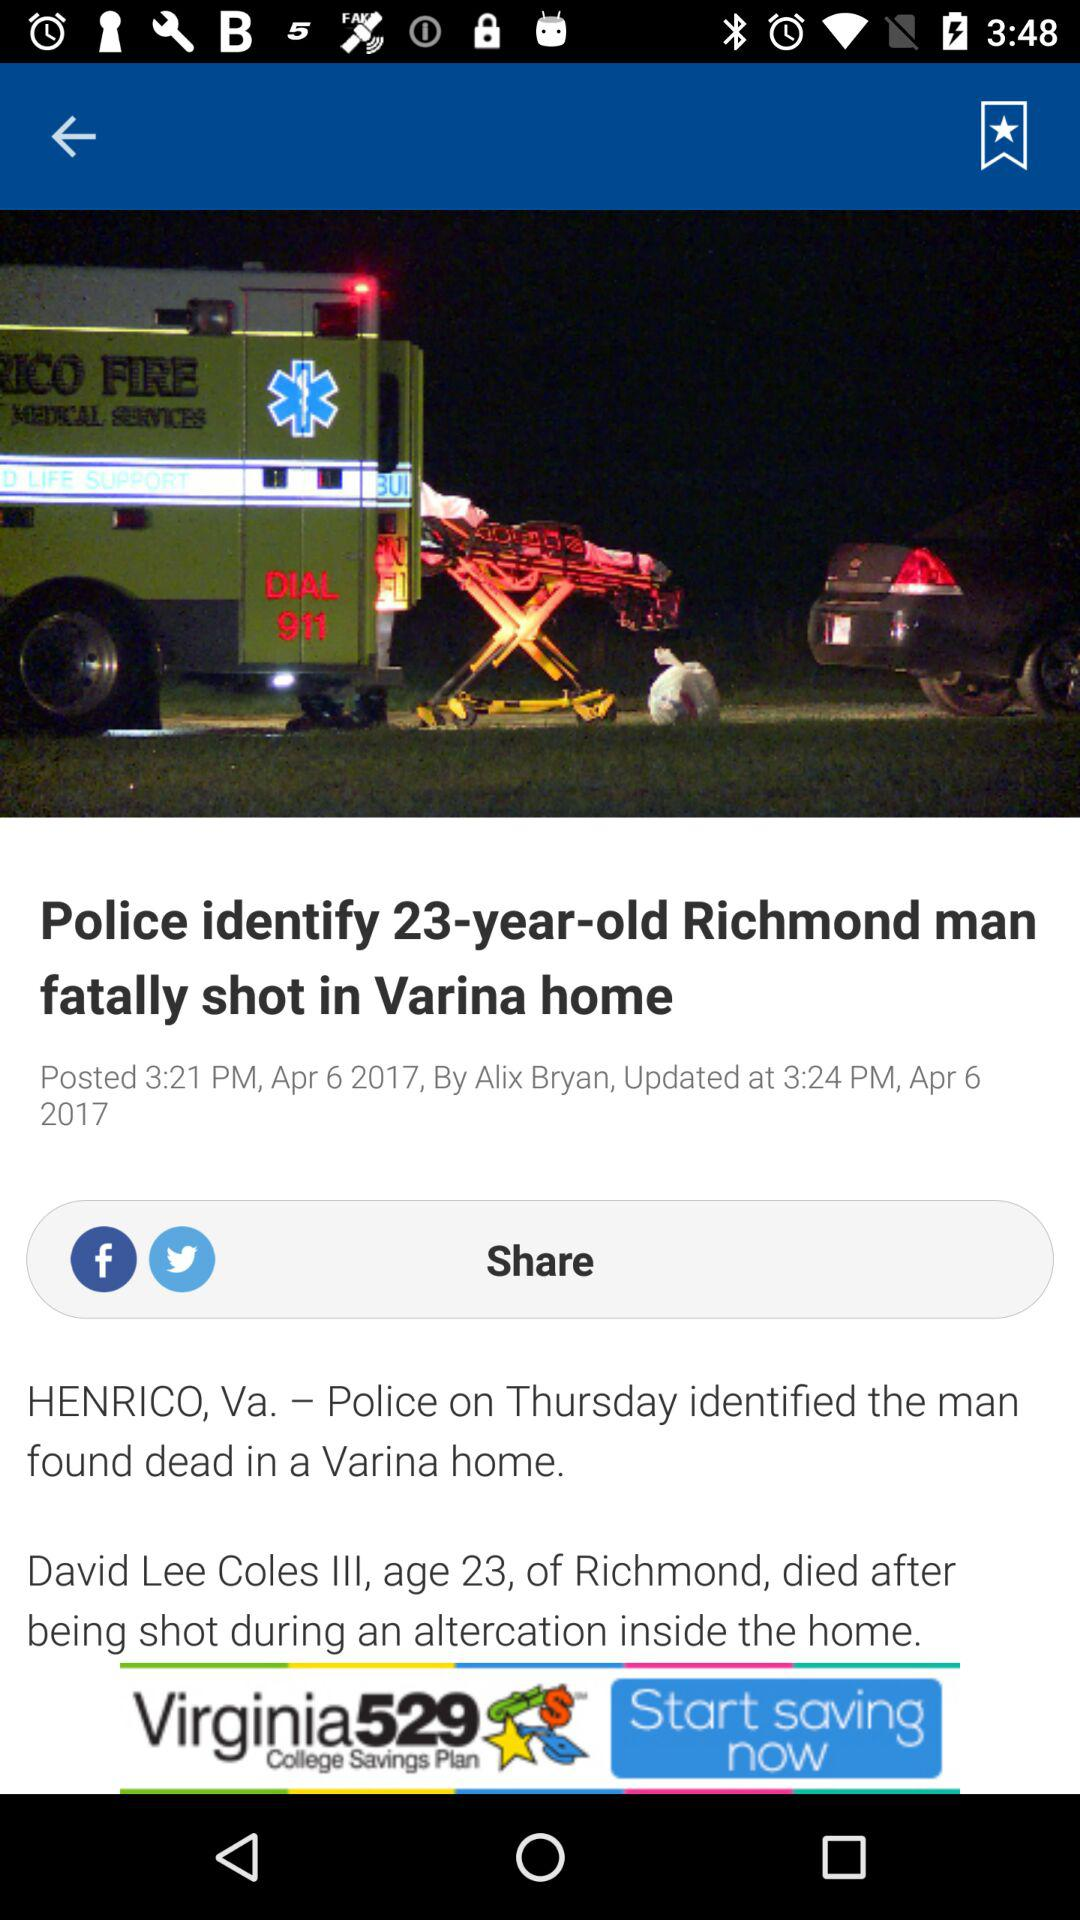On what date and time was the news "Police identify 23-year-old Richmond man fatally shot in Varina home" published? The news was posted on April 6, 2017 at 3:21 p.m. 